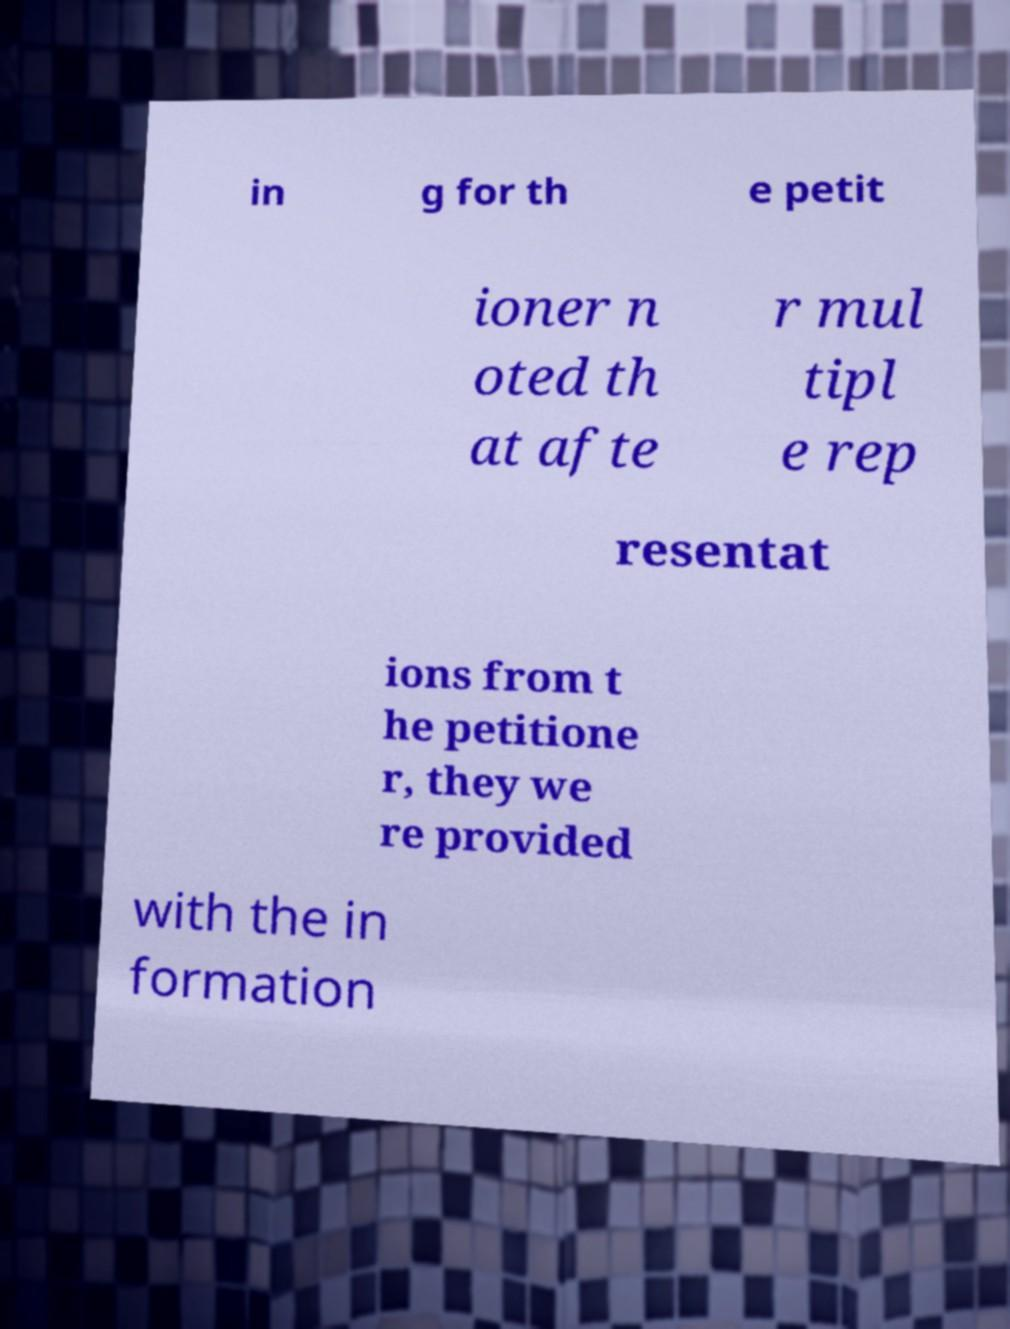Please identify and transcribe the text found in this image. in g for th e petit ioner n oted th at afte r mul tipl e rep resentat ions from t he petitione r, they we re provided with the in formation 